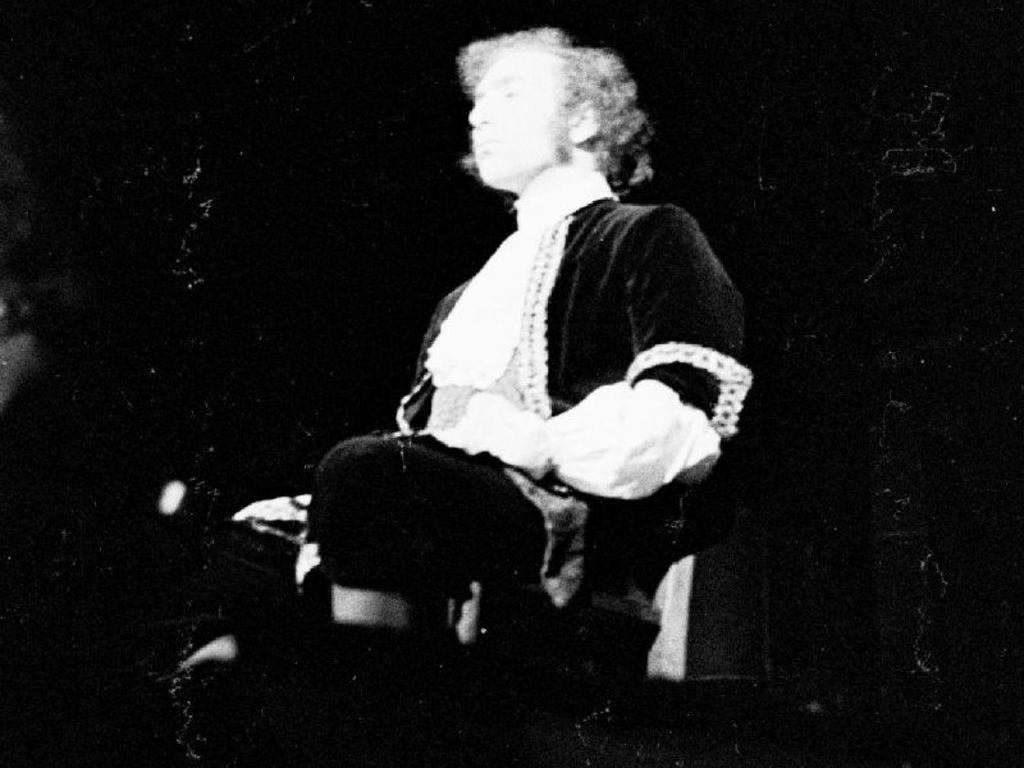What is present in the image? There is a person in the image. What is the person doing in the image? The person is sitting on a chair. What type of sand can be seen on the seat of the chair in the image? There is no sand present on the seat of the chair in the image. What type of tray is visible on the person's lap in the image? There is no tray visible on the person's lap in the image. 